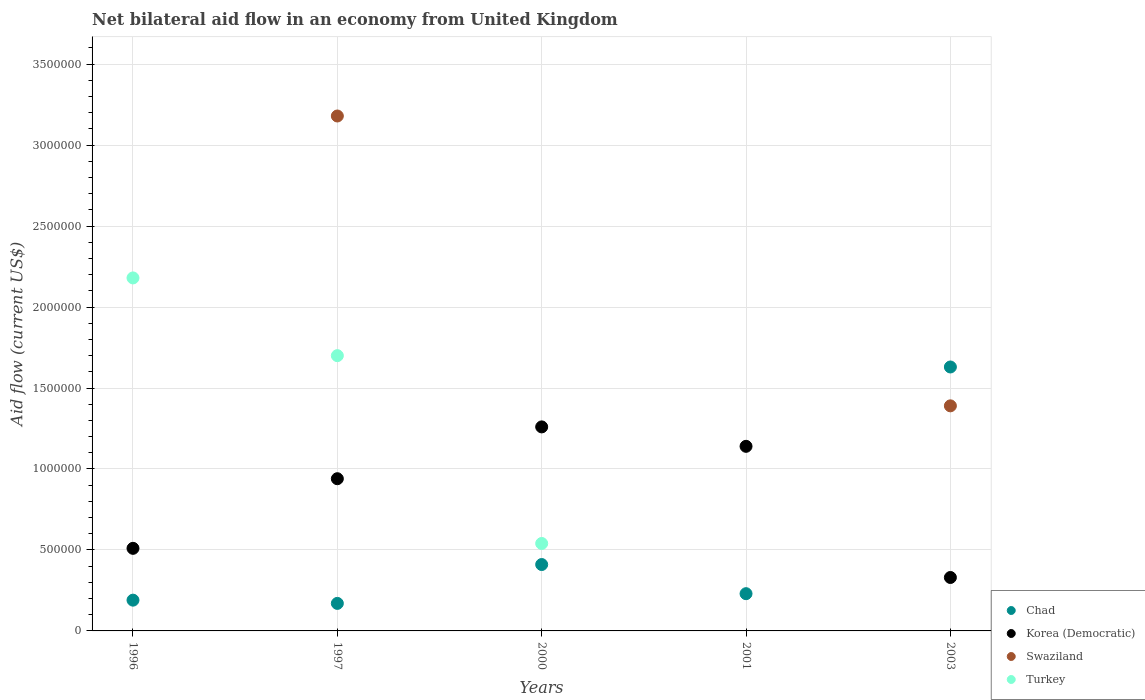Is the number of dotlines equal to the number of legend labels?
Your answer should be very brief. No. What is the net bilateral aid flow in Swaziland in 2001?
Provide a short and direct response. 0. Across all years, what is the maximum net bilateral aid flow in Turkey?
Ensure brevity in your answer.  2.18e+06. Across all years, what is the minimum net bilateral aid flow in Korea (Democratic)?
Your response must be concise. 3.30e+05. What is the total net bilateral aid flow in Korea (Democratic) in the graph?
Make the answer very short. 4.18e+06. What is the difference between the net bilateral aid flow in Turkey in 1997 and that in 2000?
Your response must be concise. 1.16e+06. What is the difference between the net bilateral aid flow in Swaziland in 1997 and the net bilateral aid flow in Chad in 2000?
Provide a succinct answer. 2.77e+06. What is the average net bilateral aid flow in Chad per year?
Provide a short and direct response. 5.26e+05. In the year 1997, what is the difference between the net bilateral aid flow in Korea (Democratic) and net bilateral aid flow in Chad?
Offer a very short reply. 7.70e+05. What is the ratio of the net bilateral aid flow in Chad in 1997 to that in 2003?
Your answer should be very brief. 0.1. What is the difference between the highest and the second highest net bilateral aid flow in Chad?
Make the answer very short. 1.22e+06. What is the difference between the highest and the lowest net bilateral aid flow in Korea (Democratic)?
Provide a short and direct response. 9.30e+05. In how many years, is the net bilateral aid flow in Turkey greater than the average net bilateral aid flow in Turkey taken over all years?
Make the answer very short. 2. Is the net bilateral aid flow in Chad strictly greater than the net bilateral aid flow in Turkey over the years?
Offer a very short reply. No. How many dotlines are there?
Offer a terse response. 4. How many years are there in the graph?
Offer a very short reply. 5. Are the values on the major ticks of Y-axis written in scientific E-notation?
Give a very brief answer. No. Does the graph contain any zero values?
Give a very brief answer. Yes. Where does the legend appear in the graph?
Offer a very short reply. Bottom right. What is the title of the graph?
Your answer should be very brief. Net bilateral aid flow in an economy from United Kingdom. What is the label or title of the X-axis?
Make the answer very short. Years. What is the Aid flow (current US$) of Korea (Democratic) in 1996?
Your response must be concise. 5.10e+05. What is the Aid flow (current US$) of Swaziland in 1996?
Keep it short and to the point. 0. What is the Aid flow (current US$) of Turkey in 1996?
Make the answer very short. 2.18e+06. What is the Aid flow (current US$) of Chad in 1997?
Offer a terse response. 1.70e+05. What is the Aid flow (current US$) of Korea (Democratic) in 1997?
Your response must be concise. 9.40e+05. What is the Aid flow (current US$) in Swaziland in 1997?
Offer a very short reply. 3.18e+06. What is the Aid flow (current US$) in Turkey in 1997?
Your answer should be compact. 1.70e+06. What is the Aid flow (current US$) of Chad in 2000?
Make the answer very short. 4.10e+05. What is the Aid flow (current US$) of Korea (Democratic) in 2000?
Ensure brevity in your answer.  1.26e+06. What is the Aid flow (current US$) of Turkey in 2000?
Your answer should be compact. 5.40e+05. What is the Aid flow (current US$) in Korea (Democratic) in 2001?
Your answer should be very brief. 1.14e+06. What is the Aid flow (current US$) in Swaziland in 2001?
Your answer should be compact. 0. What is the Aid flow (current US$) in Chad in 2003?
Your answer should be very brief. 1.63e+06. What is the Aid flow (current US$) of Swaziland in 2003?
Your answer should be compact. 1.39e+06. What is the Aid flow (current US$) in Turkey in 2003?
Provide a succinct answer. 0. Across all years, what is the maximum Aid flow (current US$) in Chad?
Provide a short and direct response. 1.63e+06. Across all years, what is the maximum Aid flow (current US$) of Korea (Democratic)?
Provide a succinct answer. 1.26e+06. Across all years, what is the maximum Aid flow (current US$) of Swaziland?
Offer a very short reply. 3.18e+06. Across all years, what is the maximum Aid flow (current US$) in Turkey?
Provide a succinct answer. 2.18e+06. Across all years, what is the minimum Aid flow (current US$) in Chad?
Provide a short and direct response. 1.70e+05. Across all years, what is the minimum Aid flow (current US$) in Swaziland?
Offer a very short reply. 0. What is the total Aid flow (current US$) of Chad in the graph?
Your response must be concise. 2.63e+06. What is the total Aid flow (current US$) of Korea (Democratic) in the graph?
Your response must be concise. 4.18e+06. What is the total Aid flow (current US$) of Swaziland in the graph?
Provide a succinct answer. 4.57e+06. What is the total Aid flow (current US$) of Turkey in the graph?
Provide a succinct answer. 4.42e+06. What is the difference between the Aid flow (current US$) of Korea (Democratic) in 1996 and that in 1997?
Keep it short and to the point. -4.30e+05. What is the difference between the Aid flow (current US$) in Turkey in 1996 and that in 1997?
Provide a succinct answer. 4.80e+05. What is the difference between the Aid flow (current US$) of Chad in 1996 and that in 2000?
Your answer should be very brief. -2.20e+05. What is the difference between the Aid flow (current US$) in Korea (Democratic) in 1996 and that in 2000?
Your answer should be very brief. -7.50e+05. What is the difference between the Aid flow (current US$) in Turkey in 1996 and that in 2000?
Offer a terse response. 1.64e+06. What is the difference between the Aid flow (current US$) in Korea (Democratic) in 1996 and that in 2001?
Offer a very short reply. -6.30e+05. What is the difference between the Aid flow (current US$) in Chad in 1996 and that in 2003?
Your answer should be compact. -1.44e+06. What is the difference between the Aid flow (current US$) in Korea (Democratic) in 1997 and that in 2000?
Ensure brevity in your answer.  -3.20e+05. What is the difference between the Aid flow (current US$) of Turkey in 1997 and that in 2000?
Your response must be concise. 1.16e+06. What is the difference between the Aid flow (current US$) in Chad in 1997 and that in 2003?
Your answer should be very brief. -1.46e+06. What is the difference between the Aid flow (current US$) of Korea (Democratic) in 1997 and that in 2003?
Keep it short and to the point. 6.10e+05. What is the difference between the Aid flow (current US$) of Swaziland in 1997 and that in 2003?
Offer a very short reply. 1.79e+06. What is the difference between the Aid flow (current US$) of Chad in 2000 and that in 2003?
Make the answer very short. -1.22e+06. What is the difference between the Aid flow (current US$) of Korea (Democratic) in 2000 and that in 2003?
Provide a succinct answer. 9.30e+05. What is the difference between the Aid flow (current US$) in Chad in 2001 and that in 2003?
Ensure brevity in your answer.  -1.40e+06. What is the difference between the Aid flow (current US$) in Korea (Democratic) in 2001 and that in 2003?
Keep it short and to the point. 8.10e+05. What is the difference between the Aid flow (current US$) in Chad in 1996 and the Aid flow (current US$) in Korea (Democratic) in 1997?
Offer a terse response. -7.50e+05. What is the difference between the Aid flow (current US$) in Chad in 1996 and the Aid flow (current US$) in Swaziland in 1997?
Your response must be concise. -2.99e+06. What is the difference between the Aid flow (current US$) of Chad in 1996 and the Aid flow (current US$) of Turkey in 1997?
Provide a succinct answer. -1.51e+06. What is the difference between the Aid flow (current US$) of Korea (Democratic) in 1996 and the Aid flow (current US$) of Swaziland in 1997?
Your answer should be compact. -2.67e+06. What is the difference between the Aid flow (current US$) in Korea (Democratic) in 1996 and the Aid flow (current US$) in Turkey in 1997?
Offer a terse response. -1.19e+06. What is the difference between the Aid flow (current US$) of Chad in 1996 and the Aid flow (current US$) of Korea (Democratic) in 2000?
Offer a very short reply. -1.07e+06. What is the difference between the Aid flow (current US$) of Chad in 1996 and the Aid flow (current US$) of Turkey in 2000?
Offer a terse response. -3.50e+05. What is the difference between the Aid flow (current US$) of Korea (Democratic) in 1996 and the Aid flow (current US$) of Turkey in 2000?
Provide a succinct answer. -3.00e+04. What is the difference between the Aid flow (current US$) of Chad in 1996 and the Aid flow (current US$) of Korea (Democratic) in 2001?
Your response must be concise. -9.50e+05. What is the difference between the Aid flow (current US$) in Chad in 1996 and the Aid flow (current US$) in Korea (Democratic) in 2003?
Offer a terse response. -1.40e+05. What is the difference between the Aid flow (current US$) of Chad in 1996 and the Aid flow (current US$) of Swaziland in 2003?
Offer a very short reply. -1.20e+06. What is the difference between the Aid flow (current US$) in Korea (Democratic) in 1996 and the Aid flow (current US$) in Swaziland in 2003?
Provide a succinct answer. -8.80e+05. What is the difference between the Aid flow (current US$) of Chad in 1997 and the Aid flow (current US$) of Korea (Democratic) in 2000?
Provide a succinct answer. -1.09e+06. What is the difference between the Aid flow (current US$) of Chad in 1997 and the Aid flow (current US$) of Turkey in 2000?
Ensure brevity in your answer.  -3.70e+05. What is the difference between the Aid flow (current US$) in Swaziland in 1997 and the Aid flow (current US$) in Turkey in 2000?
Offer a terse response. 2.64e+06. What is the difference between the Aid flow (current US$) in Chad in 1997 and the Aid flow (current US$) in Korea (Democratic) in 2001?
Offer a terse response. -9.70e+05. What is the difference between the Aid flow (current US$) of Chad in 1997 and the Aid flow (current US$) of Korea (Democratic) in 2003?
Your response must be concise. -1.60e+05. What is the difference between the Aid flow (current US$) of Chad in 1997 and the Aid flow (current US$) of Swaziland in 2003?
Give a very brief answer. -1.22e+06. What is the difference between the Aid flow (current US$) in Korea (Democratic) in 1997 and the Aid flow (current US$) in Swaziland in 2003?
Give a very brief answer. -4.50e+05. What is the difference between the Aid flow (current US$) in Chad in 2000 and the Aid flow (current US$) in Korea (Democratic) in 2001?
Provide a short and direct response. -7.30e+05. What is the difference between the Aid flow (current US$) of Chad in 2000 and the Aid flow (current US$) of Korea (Democratic) in 2003?
Give a very brief answer. 8.00e+04. What is the difference between the Aid flow (current US$) of Chad in 2000 and the Aid flow (current US$) of Swaziland in 2003?
Give a very brief answer. -9.80e+05. What is the difference between the Aid flow (current US$) of Chad in 2001 and the Aid flow (current US$) of Korea (Democratic) in 2003?
Provide a short and direct response. -1.00e+05. What is the difference between the Aid flow (current US$) of Chad in 2001 and the Aid flow (current US$) of Swaziland in 2003?
Ensure brevity in your answer.  -1.16e+06. What is the average Aid flow (current US$) of Chad per year?
Keep it short and to the point. 5.26e+05. What is the average Aid flow (current US$) of Korea (Democratic) per year?
Offer a terse response. 8.36e+05. What is the average Aid flow (current US$) in Swaziland per year?
Give a very brief answer. 9.14e+05. What is the average Aid flow (current US$) in Turkey per year?
Provide a succinct answer. 8.84e+05. In the year 1996, what is the difference between the Aid flow (current US$) of Chad and Aid flow (current US$) of Korea (Democratic)?
Provide a succinct answer. -3.20e+05. In the year 1996, what is the difference between the Aid flow (current US$) in Chad and Aid flow (current US$) in Turkey?
Provide a succinct answer. -1.99e+06. In the year 1996, what is the difference between the Aid flow (current US$) of Korea (Democratic) and Aid flow (current US$) of Turkey?
Your answer should be compact. -1.67e+06. In the year 1997, what is the difference between the Aid flow (current US$) of Chad and Aid flow (current US$) of Korea (Democratic)?
Offer a very short reply. -7.70e+05. In the year 1997, what is the difference between the Aid flow (current US$) of Chad and Aid flow (current US$) of Swaziland?
Your answer should be very brief. -3.01e+06. In the year 1997, what is the difference between the Aid flow (current US$) of Chad and Aid flow (current US$) of Turkey?
Ensure brevity in your answer.  -1.53e+06. In the year 1997, what is the difference between the Aid flow (current US$) of Korea (Democratic) and Aid flow (current US$) of Swaziland?
Provide a short and direct response. -2.24e+06. In the year 1997, what is the difference between the Aid flow (current US$) in Korea (Democratic) and Aid flow (current US$) in Turkey?
Ensure brevity in your answer.  -7.60e+05. In the year 1997, what is the difference between the Aid flow (current US$) in Swaziland and Aid flow (current US$) in Turkey?
Your response must be concise. 1.48e+06. In the year 2000, what is the difference between the Aid flow (current US$) in Chad and Aid flow (current US$) in Korea (Democratic)?
Offer a very short reply. -8.50e+05. In the year 2000, what is the difference between the Aid flow (current US$) in Korea (Democratic) and Aid flow (current US$) in Turkey?
Provide a succinct answer. 7.20e+05. In the year 2001, what is the difference between the Aid flow (current US$) in Chad and Aid flow (current US$) in Korea (Democratic)?
Offer a very short reply. -9.10e+05. In the year 2003, what is the difference between the Aid flow (current US$) in Chad and Aid flow (current US$) in Korea (Democratic)?
Provide a short and direct response. 1.30e+06. In the year 2003, what is the difference between the Aid flow (current US$) of Chad and Aid flow (current US$) of Swaziland?
Ensure brevity in your answer.  2.40e+05. In the year 2003, what is the difference between the Aid flow (current US$) of Korea (Democratic) and Aid flow (current US$) of Swaziland?
Make the answer very short. -1.06e+06. What is the ratio of the Aid flow (current US$) in Chad in 1996 to that in 1997?
Ensure brevity in your answer.  1.12. What is the ratio of the Aid flow (current US$) of Korea (Democratic) in 1996 to that in 1997?
Make the answer very short. 0.54. What is the ratio of the Aid flow (current US$) in Turkey in 1996 to that in 1997?
Your response must be concise. 1.28. What is the ratio of the Aid flow (current US$) of Chad in 1996 to that in 2000?
Offer a very short reply. 0.46. What is the ratio of the Aid flow (current US$) of Korea (Democratic) in 1996 to that in 2000?
Offer a very short reply. 0.4. What is the ratio of the Aid flow (current US$) of Turkey in 1996 to that in 2000?
Give a very brief answer. 4.04. What is the ratio of the Aid flow (current US$) in Chad in 1996 to that in 2001?
Your answer should be compact. 0.83. What is the ratio of the Aid flow (current US$) of Korea (Democratic) in 1996 to that in 2001?
Provide a short and direct response. 0.45. What is the ratio of the Aid flow (current US$) of Chad in 1996 to that in 2003?
Your answer should be compact. 0.12. What is the ratio of the Aid flow (current US$) in Korea (Democratic) in 1996 to that in 2003?
Your answer should be compact. 1.55. What is the ratio of the Aid flow (current US$) of Chad in 1997 to that in 2000?
Keep it short and to the point. 0.41. What is the ratio of the Aid flow (current US$) in Korea (Democratic) in 1997 to that in 2000?
Make the answer very short. 0.75. What is the ratio of the Aid flow (current US$) in Turkey in 1997 to that in 2000?
Your answer should be very brief. 3.15. What is the ratio of the Aid flow (current US$) in Chad in 1997 to that in 2001?
Your answer should be compact. 0.74. What is the ratio of the Aid flow (current US$) in Korea (Democratic) in 1997 to that in 2001?
Your answer should be compact. 0.82. What is the ratio of the Aid flow (current US$) in Chad in 1997 to that in 2003?
Make the answer very short. 0.1. What is the ratio of the Aid flow (current US$) in Korea (Democratic) in 1997 to that in 2003?
Provide a succinct answer. 2.85. What is the ratio of the Aid flow (current US$) of Swaziland in 1997 to that in 2003?
Your answer should be very brief. 2.29. What is the ratio of the Aid flow (current US$) in Chad in 2000 to that in 2001?
Offer a terse response. 1.78. What is the ratio of the Aid flow (current US$) of Korea (Democratic) in 2000 to that in 2001?
Make the answer very short. 1.11. What is the ratio of the Aid flow (current US$) of Chad in 2000 to that in 2003?
Your answer should be compact. 0.25. What is the ratio of the Aid flow (current US$) of Korea (Democratic) in 2000 to that in 2003?
Provide a short and direct response. 3.82. What is the ratio of the Aid flow (current US$) in Chad in 2001 to that in 2003?
Give a very brief answer. 0.14. What is the ratio of the Aid flow (current US$) in Korea (Democratic) in 2001 to that in 2003?
Make the answer very short. 3.45. What is the difference between the highest and the second highest Aid flow (current US$) in Chad?
Make the answer very short. 1.22e+06. What is the difference between the highest and the second highest Aid flow (current US$) of Turkey?
Your answer should be compact. 4.80e+05. What is the difference between the highest and the lowest Aid flow (current US$) of Chad?
Your answer should be compact. 1.46e+06. What is the difference between the highest and the lowest Aid flow (current US$) in Korea (Democratic)?
Ensure brevity in your answer.  9.30e+05. What is the difference between the highest and the lowest Aid flow (current US$) in Swaziland?
Your answer should be compact. 3.18e+06. What is the difference between the highest and the lowest Aid flow (current US$) in Turkey?
Make the answer very short. 2.18e+06. 